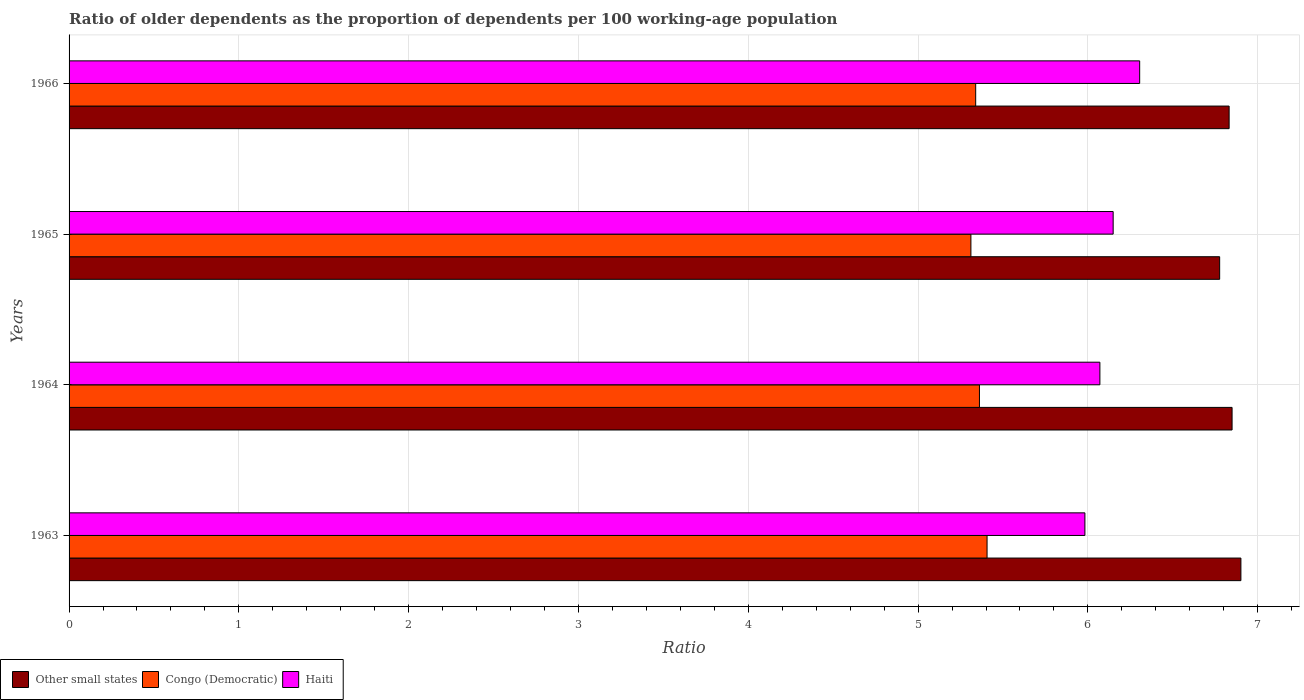How many groups of bars are there?
Offer a terse response. 4. Are the number of bars per tick equal to the number of legend labels?
Give a very brief answer. Yes. How many bars are there on the 1st tick from the top?
Make the answer very short. 3. What is the age dependency ratio(old) in Congo (Democratic) in 1963?
Your answer should be very brief. 5.41. Across all years, what is the maximum age dependency ratio(old) in Other small states?
Provide a succinct answer. 6.9. Across all years, what is the minimum age dependency ratio(old) in Other small states?
Give a very brief answer. 6.78. In which year was the age dependency ratio(old) in Other small states minimum?
Your answer should be very brief. 1965. What is the total age dependency ratio(old) in Other small states in the graph?
Offer a terse response. 27.36. What is the difference between the age dependency ratio(old) in Other small states in 1964 and that in 1966?
Offer a terse response. 0.02. What is the difference between the age dependency ratio(old) in Congo (Democratic) in 1965 and the age dependency ratio(old) in Haiti in 1963?
Your answer should be compact. -0.67. What is the average age dependency ratio(old) in Haiti per year?
Your answer should be compact. 6.13. In the year 1965, what is the difference between the age dependency ratio(old) in Haiti and age dependency ratio(old) in Congo (Democratic)?
Your response must be concise. 0.84. What is the ratio of the age dependency ratio(old) in Other small states in 1963 to that in 1964?
Provide a succinct answer. 1.01. What is the difference between the highest and the second highest age dependency ratio(old) in Other small states?
Ensure brevity in your answer.  0.05. What is the difference between the highest and the lowest age dependency ratio(old) in Other small states?
Give a very brief answer. 0.13. In how many years, is the age dependency ratio(old) in Haiti greater than the average age dependency ratio(old) in Haiti taken over all years?
Make the answer very short. 2. What does the 1st bar from the top in 1965 represents?
Your answer should be very brief. Haiti. What does the 2nd bar from the bottom in 1964 represents?
Your answer should be very brief. Congo (Democratic). How many bars are there?
Offer a terse response. 12. Are all the bars in the graph horizontal?
Offer a terse response. Yes. Are the values on the major ticks of X-axis written in scientific E-notation?
Your response must be concise. No. Where does the legend appear in the graph?
Offer a terse response. Bottom left. How many legend labels are there?
Your answer should be compact. 3. How are the legend labels stacked?
Offer a terse response. Horizontal. What is the title of the graph?
Your response must be concise. Ratio of older dependents as the proportion of dependents per 100 working-age population. What is the label or title of the X-axis?
Offer a terse response. Ratio. What is the label or title of the Y-axis?
Provide a short and direct response. Years. What is the Ratio of Other small states in 1963?
Offer a very short reply. 6.9. What is the Ratio of Congo (Democratic) in 1963?
Offer a very short reply. 5.41. What is the Ratio in Haiti in 1963?
Make the answer very short. 5.98. What is the Ratio of Other small states in 1964?
Keep it short and to the point. 6.85. What is the Ratio of Congo (Democratic) in 1964?
Your response must be concise. 5.36. What is the Ratio in Haiti in 1964?
Offer a terse response. 6.07. What is the Ratio of Other small states in 1965?
Your response must be concise. 6.78. What is the Ratio of Congo (Democratic) in 1965?
Ensure brevity in your answer.  5.31. What is the Ratio in Haiti in 1965?
Ensure brevity in your answer.  6.15. What is the Ratio of Other small states in 1966?
Your answer should be very brief. 6.83. What is the Ratio of Congo (Democratic) in 1966?
Keep it short and to the point. 5.34. What is the Ratio of Haiti in 1966?
Ensure brevity in your answer.  6.31. Across all years, what is the maximum Ratio in Other small states?
Ensure brevity in your answer.  6.9. Across all years, what is the maximum Ratio of Congo (Democratic)?
Ensure brevity in your answer.  5.41. Across all years, what is the maximum Ratio in Haiti?
Ensure brevity in your answer.  6.31. Across all years, what is the minimum Ratio in Other small states?
Offer a very short reply. 6.78. Across all years, what is the minimum Ratio of Congo (Democratic)?
Ensure brevity in your answer.  5.31. Across all years, what is the minimum Ratio in Haiti?
Provide a short and direct response. 5.98. What is the total Ratio of Other small states in the graph?
Give a very brief answer. 27.36. What is the total Ratio of Congo (Democratic) in the graph?
Keep it short and to the point. 21.42. What is the total Ratio of Haiti in the graph?
Provide a short and direct response. 24.51. What is the difference between the Ratio of Other small states in 1963 and that in 1964?
Provide a succinct answer. 0.05. What is the difference between the Ratio in Congo (Democratic) in 1963 and that in 1964?
Your response must be concise. 0.04. What is the difference between the Ratio of Haiti in 1963 and that in 1964?
Offer a very short reply. -0.09. What is the difference between the Ratio of Other small states in 1963 and that in 1965?
Ensure brevity in your answer.  0.13. What is the difference between the Ratio of Congo (Democratic) in 1963 and that in 1965?
Your answer should be compact. 0.1. What is the difference between the Ratio in Haiti in 1963 and that in 1965?
Make the answer very short. -0.17. What is the difference between the Ratio in Other small states in 1963 and that in 1966?
Ensure brevity in your answer.  0.07. What is the difference between the Ratio in Congo (Democratic) in 1963 and that in 1966?
Offer a very short reply. 0.07. What is the difference between the Ratio in Haiti in 1963 and that in 1966?
Provide a short and direct response. -0.32. What is the difference between the Ratio of Other small states in 1964 and that in 1965?
Offer a very short reply. 0.07. What is the difference between the Ratio of Congo (Democratic) in 1964 and that in 1965?
Offer a terse response. 0.05. What is the difference between the Ratio in Haiti in 1964 and that in 1965?
Your answer should be compact. -0.08. What is the difference between the Ratio of Other small states in 1964 and that in 1966?
Your answer should be compact. 0.02. What is the difference between the Ratio in Congo (Democratic) in 1964 and that in 1966?
Make the answer very short. 0.02. What is the difference between the Ratio of Haiti in 1964 and that in 1966?
Offer a terse response. -0.23. What is the difference between the Ratio of Other small states in 1965 and that in 1966?
Ensure brevity in your answer.  -0.06. What is the difference between the Ratio of Congo (Democratic) in 1965 and that in 1966?
Ensure brevity in your answer.  -0.03. What is the difference between the Ratio of Haiti in 1965 and that in 1966?
Keep it short and to the point. -0.16. What is the difference between the Ratio in Other small states in 1963 and the Ratio in Congo (Democratic) in 1964?
Provide a succinct answer. 1.54. What is the difference between the Ratio of Other small states in 1963 and the Ratio of Haiti in 1964?
Ensure brevity in your answer.  0.83. What is the difference between the Ratio of Congo (Democratic) in 1963 and the Ratio of Haiti in 1964?
Offer a very short reply. -0.66. What is the difference between the Ratio in Other small states in 1963 and the Ratio in Congo (Democratic) in 1965?
Offer a very short reply. 1.59. What is the difference between the Ratio of Other small states in 1963 and the Ratio of Haiti in 1965?
Your answer should be compact. 0.75. What is the difference between the Ratio of Congo (Democratic) in 1963 and the Ratio of Haiti in 1965?
Offer a terse response. -0.74. What is the difference between the Ratio of Other small states in 1963 and the Ratio of Congo (Democratic) in 1966?
Your answer should be very brief. 1.56. What is the difference between the Ratio of Other small states in 1963 and the Ratio of Haiti in 1966?
Make the answer very short. 0.6. What is the difference between the Ratio of Congo (Democratic) in 1963 and the Ratio of Haiti in 1966?
Make the answer very short. -0.9. What is the difference between the Ratio in Other small states in 1964 and the Ratio in Congo (Democratic) in 1965?
Ensure brevity in your answer.  1.54. What is the difference between the Ratio in Other small states in 1964 and the Ratio in Haiti in 1965?
Ensure brevity in your answer.  0.7. What is the difference between the Ratio of Congo (Democratic) in 1964 and the Ratio of Haiti in 1965?
Make the answer very short. -0.79. What is the difference between the Ratio of Other small states in 1964 and the Ratio of Congo (Democratic) in 1966?
Offer a terse response. 1.51. What is the difference between the Ratio in Other small states in 1964 and the Ratio in Haiti in 1966?
Your answer should be very brief. 0.54. What is the difference between the Ratio in Congo (Democratic) in 1964 and the Ratio in Haiti in 1966?
Ensure brevity in your answer.  -0.94. What is the difference between the Ratio in Other small states in 1965 and the Ratio in Congo (Democratic) in 1966?
Offer a terse response. 1.44. What is the difference between the Ratio of Other small states in 1965 and the Ratio of Haiti in 1966?
Give a very brief answer. 0.47. What is the difference between the Ratio in Congo (Democratic) in 1965 and the Ratio in Haiti in 1966?
Keep it short and to the point. -0.99. What is the average Ratio of Other small states per year?
Ensure brevity in your answer.  6.84. What is the average Ratio of Congo (Democratic) per year?
Ensure brevity in your answer.  5.35. What is the average Ratio of Haiti per year?
Make the answer very short. 6.13. In the year 1963, what is the difference between the Ratio of Other small states and Ratio of Congo (Democratic)?
Offer a terse response. 1.49. In the year 1963, what is the difference between the Ratio of Other small states and Ratio of Haiti?
Make the answer very short. 0.92. In the year 1963, what is the difference between the Ratio in Congo (Democratic) and Ratio in Haiti?
Your answer should be compact. -0.58. In the year 1964, what is the difference between the Ratio of Other small states and Ratio of Congo (Democratic)?
Offer a very short reply. 1.49. In the year 1964, what is the difference between the Ratio in Other small states and Ratio in Haiti?
Your response must be concise. 0.78. In the year 1964, what is the difference between the Ratio of Congo (Democratic) and Ratio of Haiti?
Your answer should be very brief. -0.71. In the year 1965, what is the difference between the Ratio of Other small states and Ratio of Congo (Democratic)?
Your response must be concise. 1.46. In the year 1965, what is the difference between the Ratio of Other small states and Ratio of Haiti?
Give a very brief answer. 0.63. In the year 1965, what is the difference between the Ratio in Congo (Democratic) and Ratio in Haiti?
Ensure brevity in your answer.  -0.84. In the year 1966, what is the difference between the Ratio in Other small states and Ratio in Congo (Democratic)?
Give a very brief answer. 1.49. In the year 1966, what is the difference between the Ratio in Other small states and Ratio in Haiti?
Make the answer very short. 0.53. In the year 1966, what is the difference between the Ratio of Congo (Democratic) and Ratio of Haiti?
Offer a terse response. -0.97. What is the ratio of the Ratio of Other small states in 1963 to that in 1964?
Ensure brevity in your answer.  1.01. What is the ratio of the Ratio of Congo (Democratic) in 1963 to that in 1964?
Your answer should be very brief. 1.01. What is the ratio of the Ratio in Haiti in 1963 to that in 1964?
Your answer should be compact. 0.99. What is the ratio of the Ratio of Other small states in 1963 to that in 1965?
Offer a terse response. 1.02. What is the ratio of the Ratio in Congo (Democratic) in 1963 to that in 1965?
Give a very brief answer. 1.02. What is the ratio of the Ratio in Haiti in 1963 to that in 1965?
Your response must be concise. 0.97. What is the ratio of the Ratio in Congo (Democratic) in 1963 to that in 1966?
Offer a very short reply. 1.01. What is the ratio of the Ratio in Haiti in 1963 to that in 1966?
Your response must be concise. 0.95. What is the ratio of the Ratio of Other small states in 1964 to that in 1965?
Ensure brevity in your answer.  1.01. What is the ratio of the Ratio in Congo (Democratic) in 1964 to that in 1965?
Provide a succinct answer. 1.01. What is the ratio of the Ratio of Haiti in 1964 to that in 1965?
Ensure brevity in your answer.  0.99. What is the ratio of the Ratio in Other small states in 1964 to that in 1966?
Keep it short and to the point. 1. What is the ratio of the Ratio in Congo (Democratic) in 1964 to that in 1966?
Ensure brevity in your answer.  1. What is the ratio of the Ratio in Haiti in 1964 to that in 1966?
Make the answer very short. 0.96. What is the ratio of the Ratio in Other small states in 1965 to that in 1966?
Keep it short and to the point. 0.99. What is the ratio of the Ratio in Haiti in 1965 to that in 1966?
Your response must be concise. 0.98. What is the difference between the highest and the second highest Ratio of Other small states?
Provide a short and direct response. 0.05. What is the difference between the highest and the second highest Ratio of Congo (Democratic)?
Your answer should be very brief. 0.04. What is the difference between the highest and the second highest Ratio of Haiti?
Keep it short and to the point. 0.16. What is the difference between the highest and the lowest Ratio in Other small states?
Your answer should be very brief. 0.13. What is the difference between the highest and the lowest Ratio in Congo (Democratic)?
Offer a very short reply. 0.1. What is the difference between the highest and the lowest Ratio in Haiti?
Make the answer very short. 0.32. 